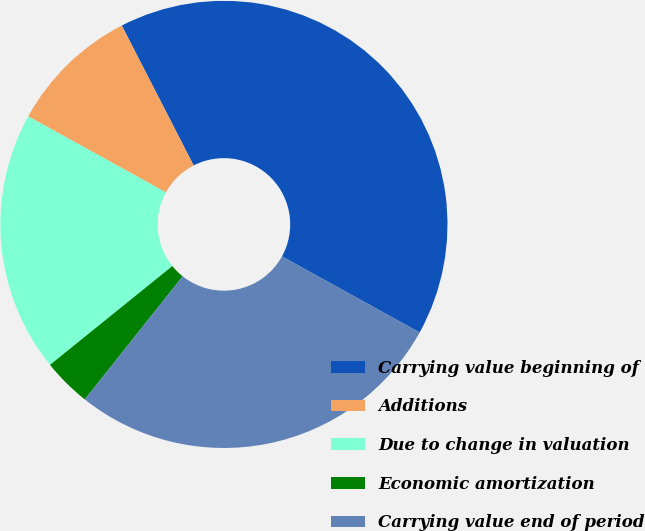Convert chart to OTSL. <chart><loc_0><loc_0><loc_500><loc_500><pie_chart><fcel>Carrying value beginning of<fcel>Additions<fcel>Due to change in valuation<fcel>Economic amortization<fcel>Carrying value end of period<nl><fcel>40.58%<fcel>9.42%<fcel>18.84%<fcel>3.5%<fcel>27.66%<nl></chart> 